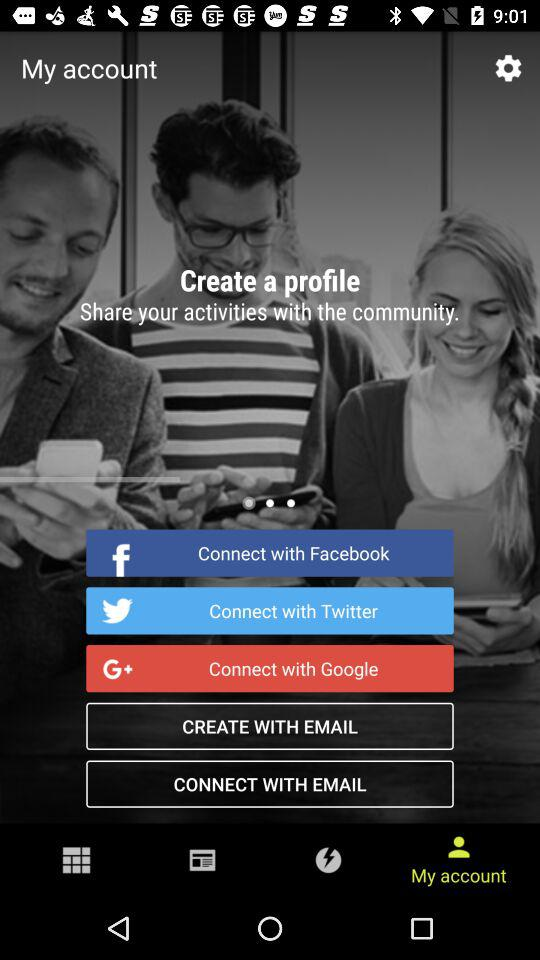How many articles are there in "Samsung"? There are 700 articles in "Samsung". 